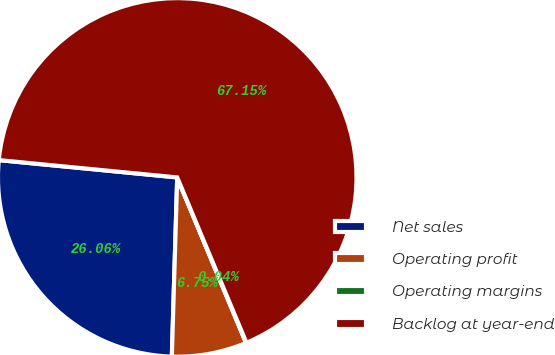Convert chart. <chart><loc_0><loc_0><loc_500><loc_500><pie_chart><fcel>Net sales<fcel>Operating profit<fcel>Operating margins<fcel>Backlog at year-end<nl><fcel>26.06%<fcel>6.75%<fcel>0.04%<fcel>67.14%<nl></chart> 